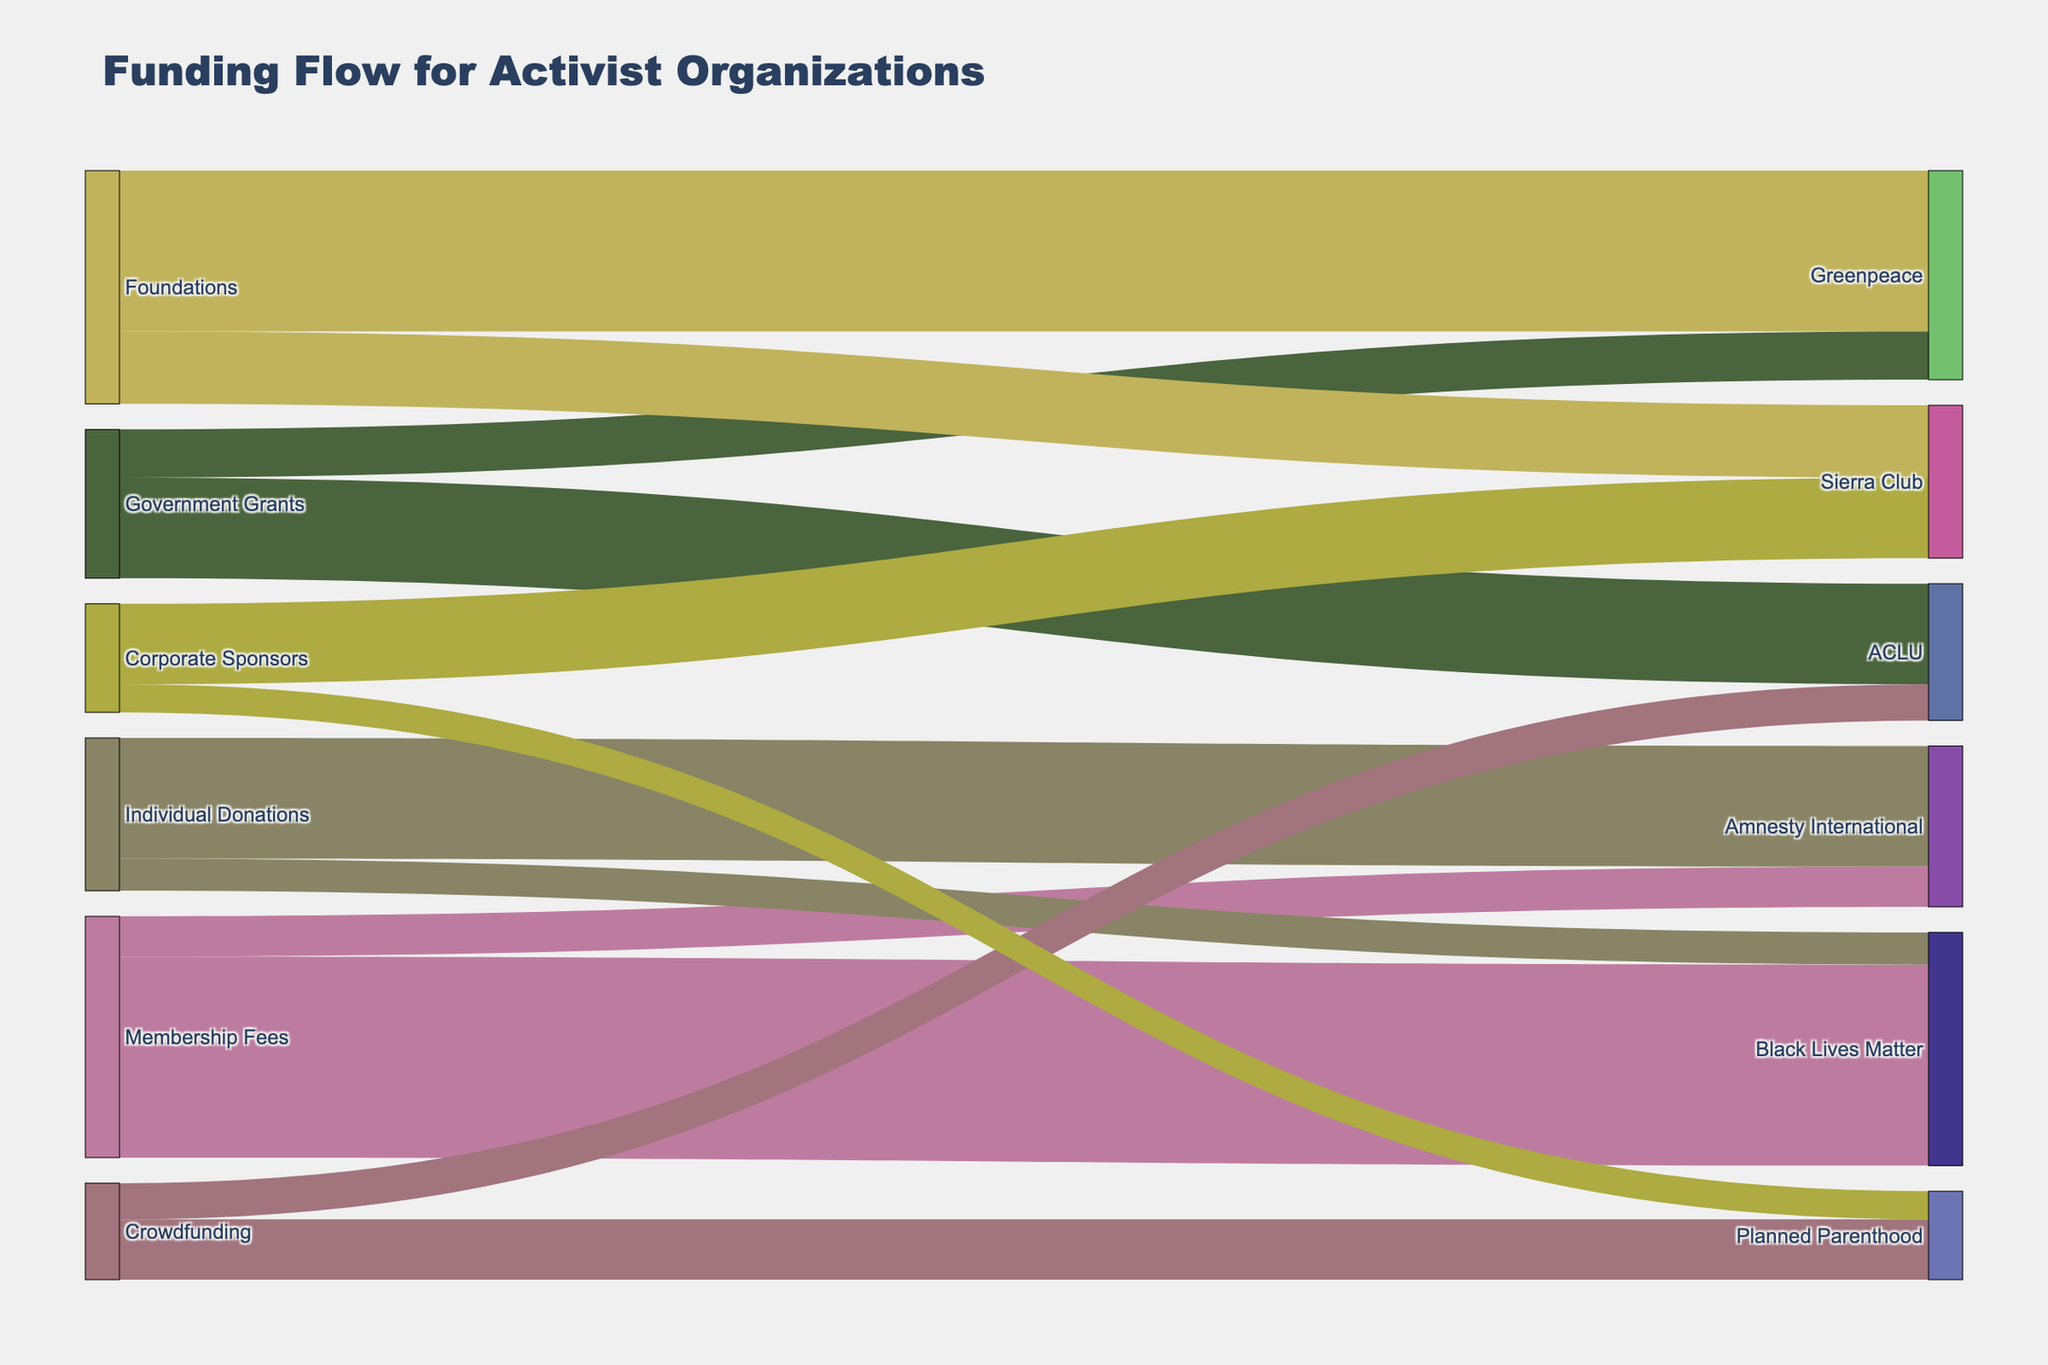Which funding source contributes the most to Environmental Campaigns? The figure shows that individual donations contribute significantly to various activist organizations. By tracing the flow, we can see that individual donations provide the largest funding for Greenpeace's Environmental Campaigns.
Answer: Individual Donations What is the total amount of funds received by ACLU from all sources? The figure reveals that ACLU receives funds from government grants and foundations. Summing up the values from these sources gives 4,000,000 + 1,200,000 = 5,200,000.
Answer: 5,200,000 Which organization receives the most funding from corporate sponsors? From the figure, we can observe the connections between corporate sponsors and various organizations. Amnesty International receives the highest funding from corporate sponsors with a total of 3,000,000.
Answer: Amnesty International How much funding does Planned Parenthood receive for Healthcare Services and Policy Development combined? Planned Parenthood receives 2,000,000 for Healthcare Services and 1,800,000 for Policy Development. Adding these amounts yields 2,000,000 + 1,800,000 = 3,800,000.
Answer: 3,800,000 Compare the funding received by Greenpeace's Environmental Campaigns and Media Relations. Which is higher? Greenpeace gets 5,000,000 for Environmental Campaigns and 800,000 for Media Relations. Comparing these, Environmental Campaigns receive remarkably higher funding.
Answer: Environmental Campaigns How does the funding for Sierra Club's Lobbying activities compare to its Conservation Projects? Sierra Club receives 1,500,000 for Lobbying and 700,000 for Conservation Projects. Thus, the funding for Lobbying is more than double that of Conservation Projects.
Answer: Lobbying Identify the organization that has the most diverse sources of funding. By observing the number of different source links connected to each organization, it is clear that Planned Parenthood has funds from three different sources: government grants, crowdfunding, and individual donations.
Answer: Planned Parenthood What is the combined funding amount for Human Rights Advocacy and Research activities carried out by Amnesty International? Amnesty International's Human Rights Advocacy receives 3,000,000 and its Research gets 1,000,000. Summing these amounts gives 3,000,000 + 1,000,000 = 4,000,000.
Answer: 4,000,000 